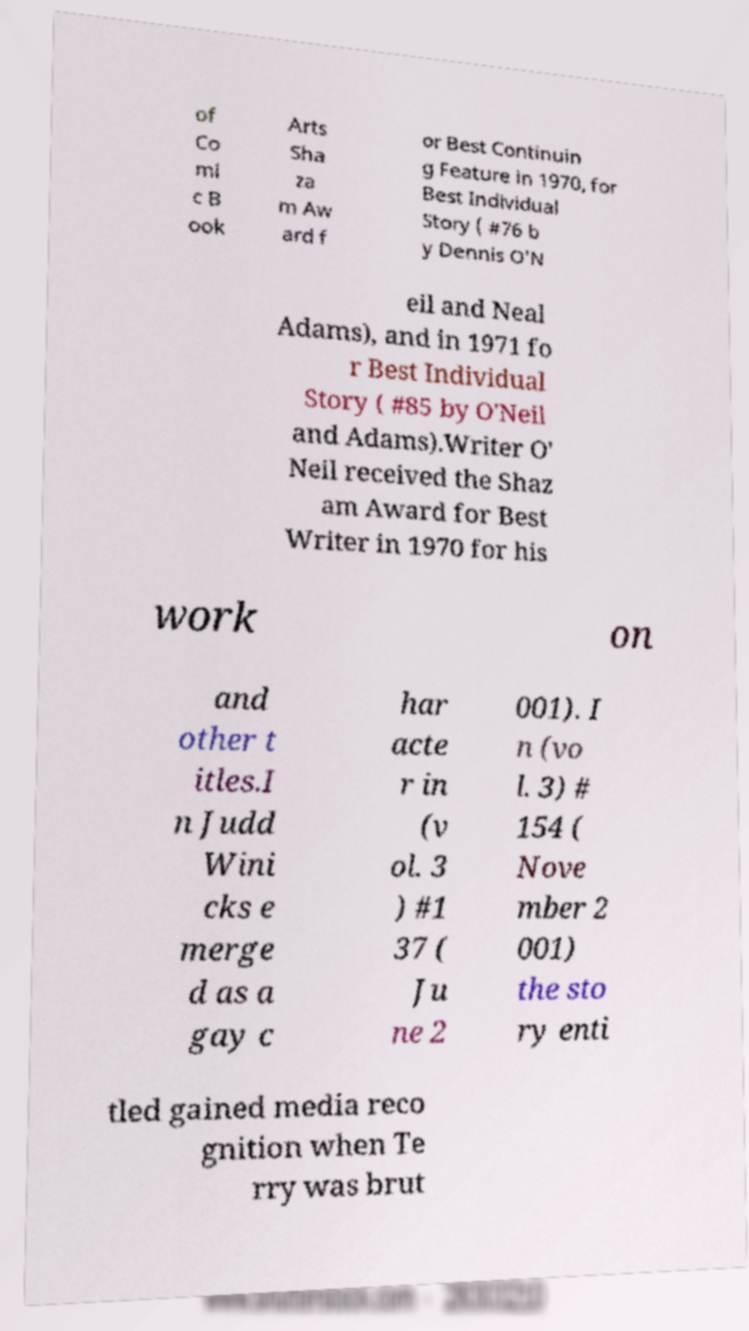Can you read and provide the text displayed in the image?This photo seems to have some interesting text. Can you extract and type it out for me? of Co mi c B ook Arts Sha za m Aw ard f or Best Continuin g Feature in 1970, for Best Individual Story ( #76 b y Dennis O'N eil and Neal Adams), and in 1971 fo r Best Individual Story ( #85 by O'Neil and Adams).Writer O' Neil received the Shaz am Award for Best Writer in 1970 for his work on and other t itles.I n Judd Wini cks e merge d as a gay c har acte r in (v ol. 3 ) #1 37 ( Ju ne 2 001). I n (vo l. 3) # 154 ( Nove mber 2 001) the sto ry enti tled gained media reco gnition when Te rry was brut 